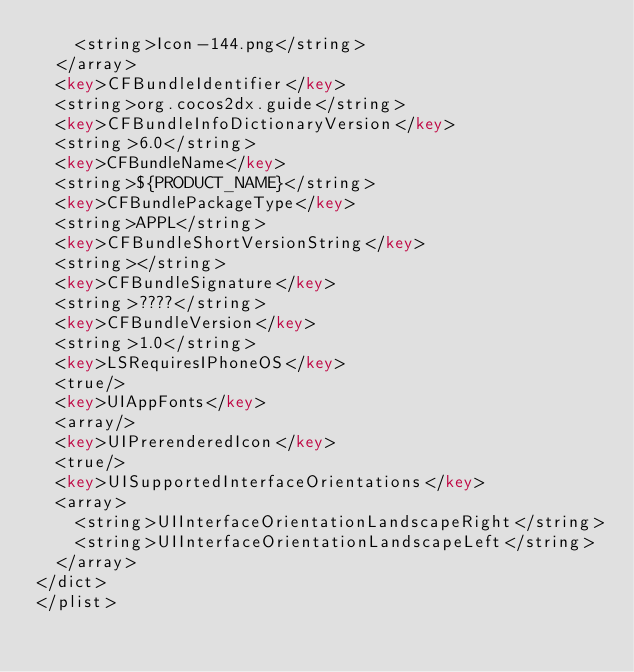Convert code to text. <code><loc_0><loc_0><loc_500><loc_500><_XML_>		<string>Icon-144.png</string>
	</array>
	<key>CFBundleIdentifier</key>
	<string>org.cocos2dx.guide</string>
	<key>CFBundleInfoDictionaryVersion</key>
	<string>6.0</string>
	<key>CFBundleName</key>
	<string>${PRODUCT_NAME}</string>
	<key>CFBundlePackageType</key>
	<string>APPL</string>
	<key>CFBundleShortVersionString</key>
	<string></string>
	<key>CFBundleSignature</key>
	<string>????</string>
	<key>CFBundleVersion</key>
	<string>1.0</string>
	<key>LSRequiresIPhoneOS</key>
	<true/>
	<key>UIAppFonts</key>
	<array/>
	<key>UIPrerenderedIcon</key>
	<true/>
	<key>UISupportedInterfaceOrientations</key>
	<array>
		<string>UIInterfaceOrientationLandscapeRight</string>
		<string>UIInterfaceOrientationLandscapeLeft</string>
	</array>
</dict>
</plist>
</code> 